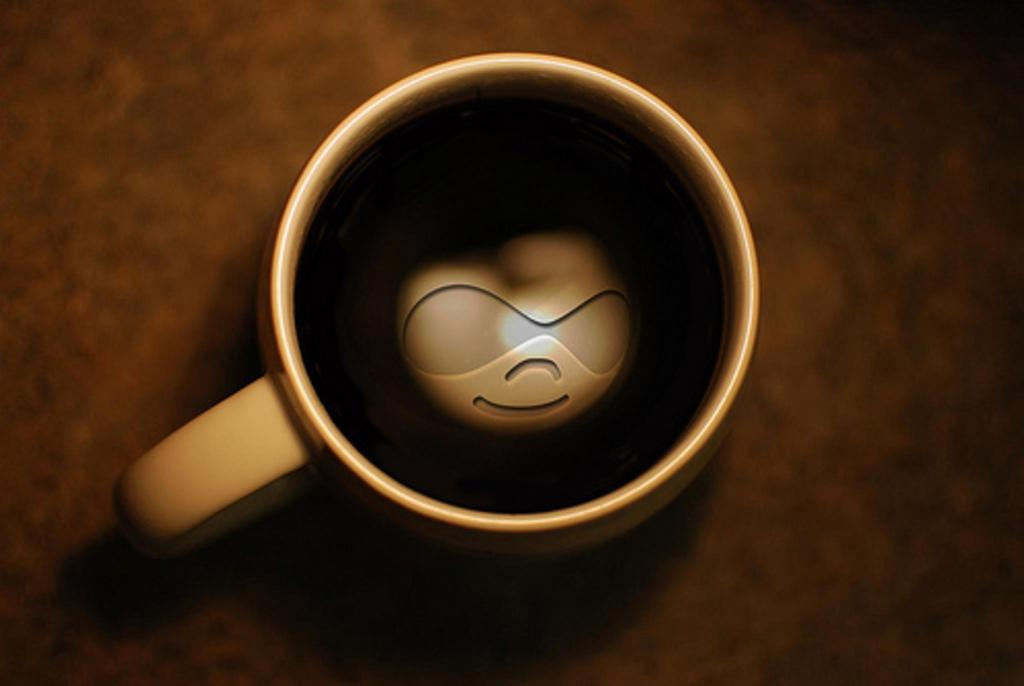What is in the cup that is visible in the image? There is a cup with a drink in the image. What can be seen inside the drink? There is a brown-colored object in the drink. What is the color of the surface the cup is placed on? The cup is on a brown-colored surface. How many ladybugs are crawling on the cup in the image? There are no ladybugs present in the image. What type of shade is provided by the cup in the image? The cup does not provide any shade in the image, as it is a single object and not a structure. 